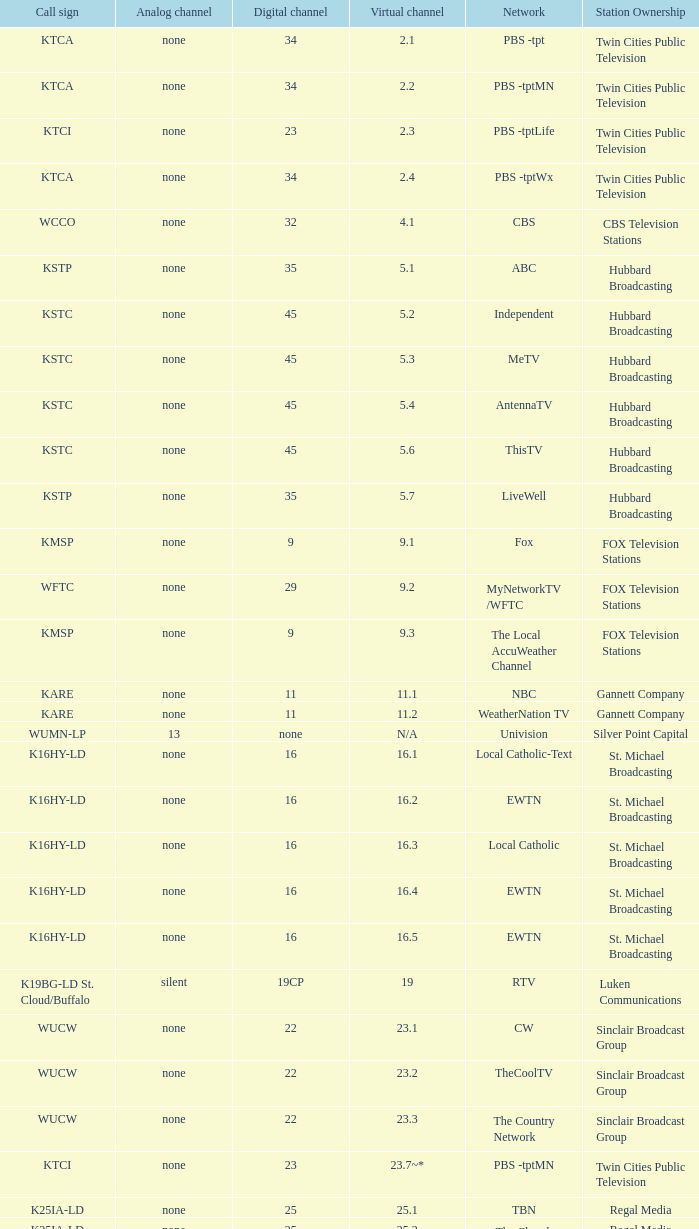I'm looking to parse the entire table for insights. Could you assist me with that? {'header': ['Call sign', 'Analog channel', 'Digital channel', 'Virtual channel', 'Network', 'Station Ownership'], 'rows': [['KTCA', 'none', '34', '2.1', 'PBS -tpt', 'Twin Cities Public Television'], ['KTCA', 'none', '34', '2.2', 'PBS -tptMN', 'Twin Cities Public Television'], ['KTCI', 'none', '23', '2.3', 'PBS -tptLife', 'Twin Cities Public Television'], ['KTCA', 'none', '34', '2.4', 'PBS -tptWx', 'Twin Cities Public Television'], ['WCCO', 'none', '32', '4.1', 'CBS', 'CBS Television Stations'], ['KSTP', 'none', '35', '5.1', 'ABC', 'Hubbard Broadcasting'], ['KSTC', 'none', '45', '5.2', 'Independent', 'Hubbard Broadcasting'], ['KSTC', 'none', '45', '5.3', 'MeTV', 'Hubbard Broadcasting'], ['KSTC', 'none', '45', '5.4', 'AntennaTV', 'Hubbard Broadcasting'], ['KSTC', 'none', '45', '5.6', 'ThisTV', 'Hubbard Broadcasting'], ['KSTP', 'none', '35', '5.7', 'LiveWell', 'Hubbard Broadcasting'], ['KMSP', 'none', '9', '9.1', 'Fox', 'FOX Television Stations'], ['WFTC', 'none', '29', '9.2', 'MyNetworkTV /WFTC', 'FOX Television Stations'], ['KMSP', 'none', '9', '9.3', 'The Local AccuWeather Channel', 'FOX Television Stations'], ['KARE', 'none', '11', '11.1', 'NBC', 'Gannett Company'], ['KARE', 'none', '11', '11.2', 'WeatherNation TV', 'Gannett Company'], ['WUMN-LP', '13', 'none', 'N/A', 'Univision', 'Silver Point Capital'], ['K16HY-LD', 'none', '16', '16.1', 'Local Catholic-Text', 'St. Michael Broadcasting'], ['K16HY-LD', 'none', '16', '16.2', 'EWTN', 'St. Michael Broadcasting'], ['K16HY-LD', 'none', '16', '16.3', 'Local Catholic', 'St. Michael Broadcasting'], ['K16HY-LD', 'none', '16', '16.4', 'EWTN', 'St. Michael Broadcasting'], ['K16HY-LD', 'none', '16', '16.5', 'EWTN', 'St. Michael Broadcasting'], ['K19BG-LD St. Cloud/Buffalo', 'silent', '19CP', '19', 'RTV', 'Luken Communications'], ['WUCW', 'none', '22', '23.1', 'CW', 'Sinclair Broadcast Group'], ['WUCW', 'none', '22', '23.2', 'TheCoolTV', 'Sinclair Broadcast Group'], ['WUCW', 'none', '22', '23.3', 'The Country Network', 'Sinclair Broadcast Group'], ['KTCI', 'none', '23', '23.7~*', 'PBS -tptMN', 'Twin Cities Public Television'], ['K25IA-LD', 'none', '25', '25.1', 'TBN', 'Regal Media'], ['K25IA-LD', 'none', '25', '25.2', 'The Church Channel', 'Regal Media'], ['K25IA-LD', 'none', '25', '25.3', 'JCTV', 'Regal Media'], ['K25IA-LD', 'none', '25', '25.4', 'Smile Of A Child', 'Regal Media'], ['K25IA-LD', 'none', '25', '25.5', 'TBN Enlace', 'Regal Media'], ['W47CO-LD River Falls, Wisc.', 'none', '47', '28.1', 'PBS /WHWC', 'Wisconsin Public Television'], ['W47CO-LD River Falls, Wisc.', 'none', '47', '28.2', 'PBS -WISC/WHWC', 'Wisconsin Public Television'], ['W47CO-LD River Falls, Wisc.', 'none', '47', '28.3', 'PBS -Create/WHWC', 'Wisconsin Public Television'], ['WFTC', 'none', '29', '29.1', 'MyNetworkTV', 'FOX Television Stations'], ['KMSP', 'none', '9', '29.2', 'MyNetworkTV /WFTC', 'FOX Television Stations'], ['WFTC', 'none', '29', '29.3', 'Bounce TV', 'FOX Television Stations'], ['WFTC', 'none', '29', '29.4', 'Movies!', 'FOX Television Stations'], ['K33LN-LD', 'none', '33', '33.1', '3ABN', 'Three Angels Broadcasting Network'], ['K33LN-LD', 'none', '33', '33.2', '3ABN Proclaim!', 'Three Angels Broadcasting Network'], ['K33LN-LD', 'none', '33', '33.3', '3ABN Dare to Dream', 'Three Angels Broadcasting Network'], ['K33LN-LD', 'none', '33', '33.4', '3ABN Latino', 'Three Angels Broadcasting Network'], ['K33LN-LD', 'none', '33', '33.5', '3ABN Radio-Audio', 'Three Angels Broadcasting Network'], ['K33LN-LD', 'none', '33', '33.6', '3ABN Radio Latino-Audio', 'Three Angels Broadcasting Network'], ['K33LN-LD', 'none', '33', '33.7', 'Radio 74-Audio', 'Three Angels Broadcasting Network'], ['KPXM-TV', 'none', '40', '41.1', 'Ion Television', 'Ion Media Networks'], ['KPXM-TV', 'none', '40', '41.2', 'Qubo Kids', 'Ion Media Networks'], ['KPXM-TV', 'none', '40', '41.3', 'Ion Life', 'Ion Media Networks'], ['K43HB-LD', 'none', '43', '43.1', 'HSN', 'Ventana Television'], ['KHVM-LD', 'none', '48', '48.1', 'GCN - Religious', 'EICB TV'], ['KTCJ-LD', 'none', '50', '50.1', 'CTVN - Religious', 'EICB TV'], ['WDMI-LD', 'none', '31', '62.1', 'Daystar', 'Word of God Fellowship']]} To which analog channel does digital channel 32 relate? None. 